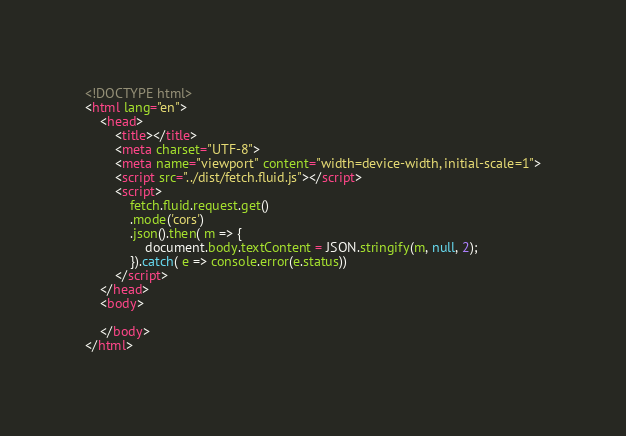Convert code to text. <code><loc_0><loc_0><loc_500><loc_500><_HTML_><!DOCTYPE html>
<html lang="en">
    <head>
        <title></title>
        <meta charset="UTF-8">
        <meta name="viewport" content="width=device-width, initial-scale=1">
        <script src="../dist/fetch.fluid.js"></script>
        <script>
            fetch.fluid.request.get()
            .mode('cors')
            .json().then( m => {
                document.body.textContent = JSON.stringify(m, null, 2);
            }).catch( e => console.error(e.status))
        </script>
    </head>
    <body>
    
    </body>
</html></code> 